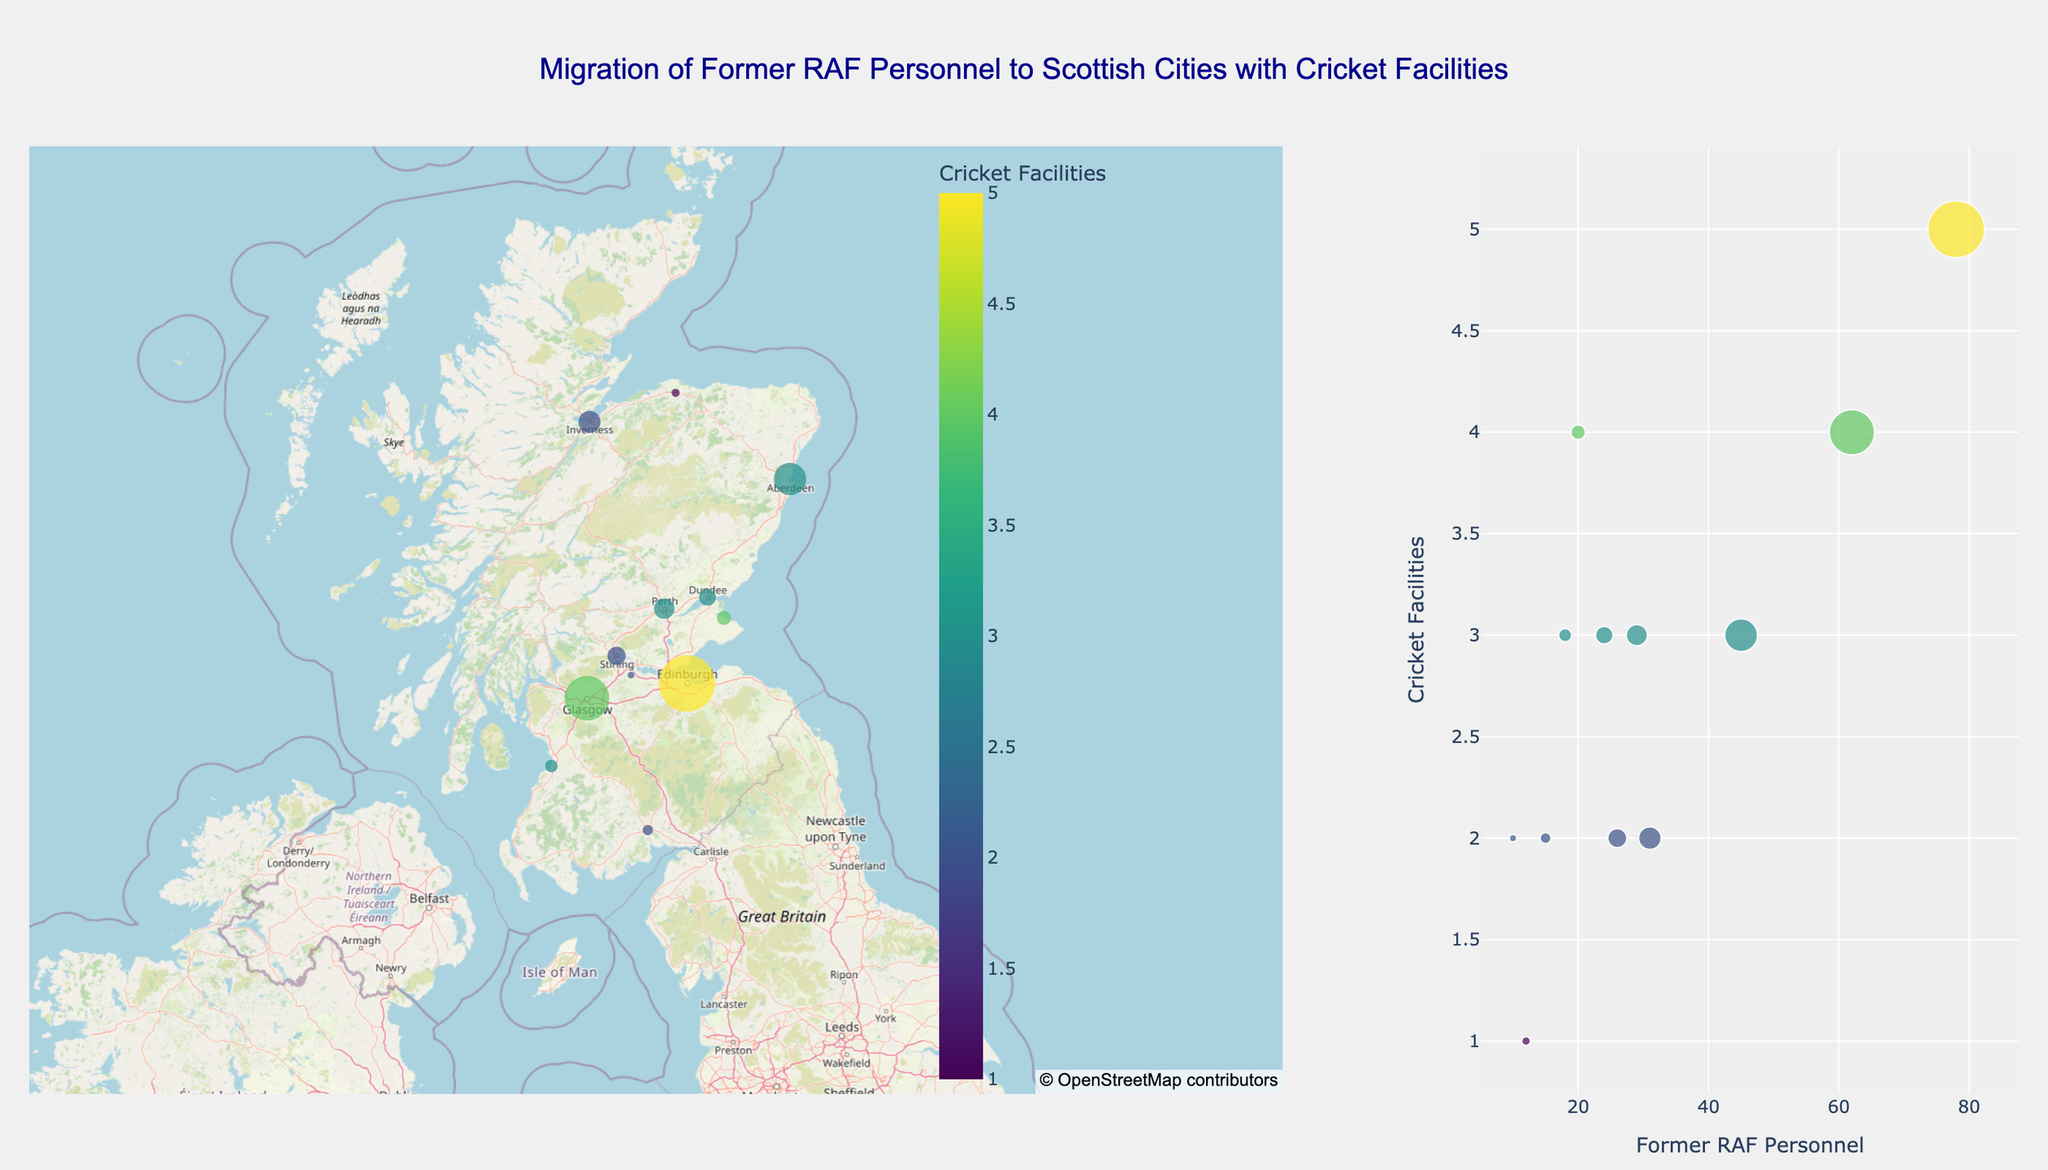How many cities are represented in the plot? Count the number of unique city markers in the mapbox plot. Each marker represents a different city.
Answer: 12 What city has the highest number of former RAF personnel? Look for the marker with the largest size in the map or the highest x-value on the bubble chart. The hover text will confirm the city.
Answer: Edinburgh How does Glasgow compare to Edinburgh in terms of former RAF personnel and cricket facilities? On the bubble chart or by hovering over the markers, compare the size and color: Edinburgh has 78 personnel and 5 facilities, while Glasgow has 62 personnel and 4 facilities.
Answer: Edinburgh has more in both categories Which city has the fewest cricket facilities? Look for the cities with the lowest number in the color scale on the map or the lowest y-value on the bubble chart.
Answer: Elgin What's the average number of cricket facilities among the cities represented? Sum the cricket facilities (5+4+3+2+3+2+3+4+3+2+1+2=34) and divide by the number of cities (34/12).
Answer: Approximately 2.83 Which cities have exactly 3 cricket facilities? Look at the markers on the map or bubble chart with the color code for 3 facilities, or refer to the data values.
Answer: Aberdeen, Perth, Dundee, Ayr Are there any cities with more than 40 former RAF personnel but fewer than 4 cricket facilities? Cross-reference the map or bubble chart for markers with sizes indicating more than 40 personnel and color codes indicating fewer than 4 facilities.
Answer: No What's the relationship between the number of former RAF personnel and cricket facilities? Observe the scatter pattern of the bubble chart: higher personnel numbers don't correspond to higher cricket facilities consistently, e.g., Edinburgh (78, 5) vs. St Andrews (20, 4).
Answer: No strong correlation Which city lies the furthest north among those with at least 15 former RAF personnel? Check the latitude values, the highest one being furthest north.
Answer: Elgin How many cities are located to the west of Edinburgh? Compare the longitudes; cities with longitudes less than Edinburgh's (-3.1883) are west. They are cities with longitude less than -3.1883.
Answer: 5 (Glasgow, Dumfries, Ayr, Inverness, Stirling) 